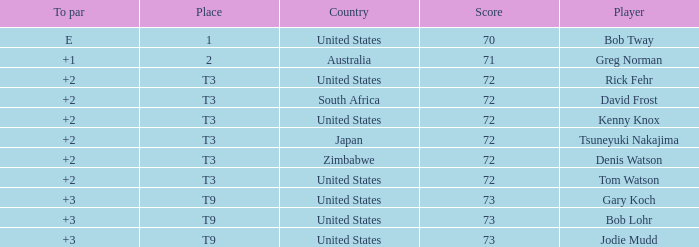What is the top score for tsuneyuki nakajima? 72.0. 